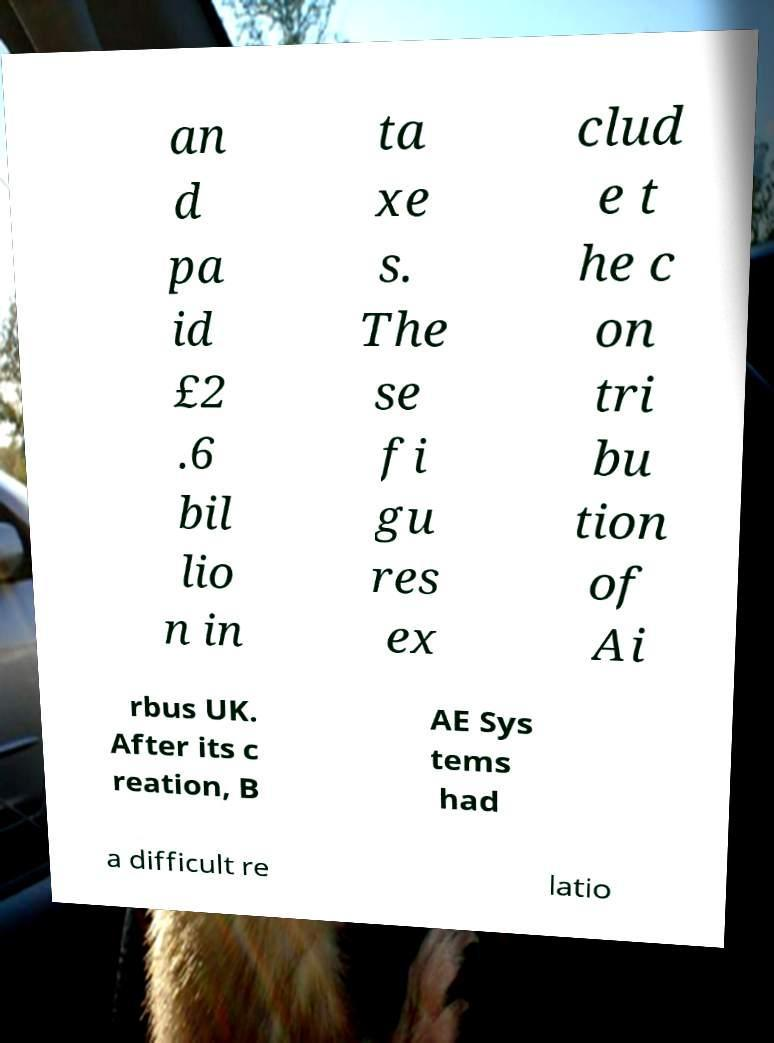Could you extract and type out the text from this image? an d pa id £2 .6 bil lio n in ta xe s. The se fi gu res ex clud e t he c on tri bu tion of Ai rbus UK. After its c reation, B AE Sys tems had a difficult re latio 